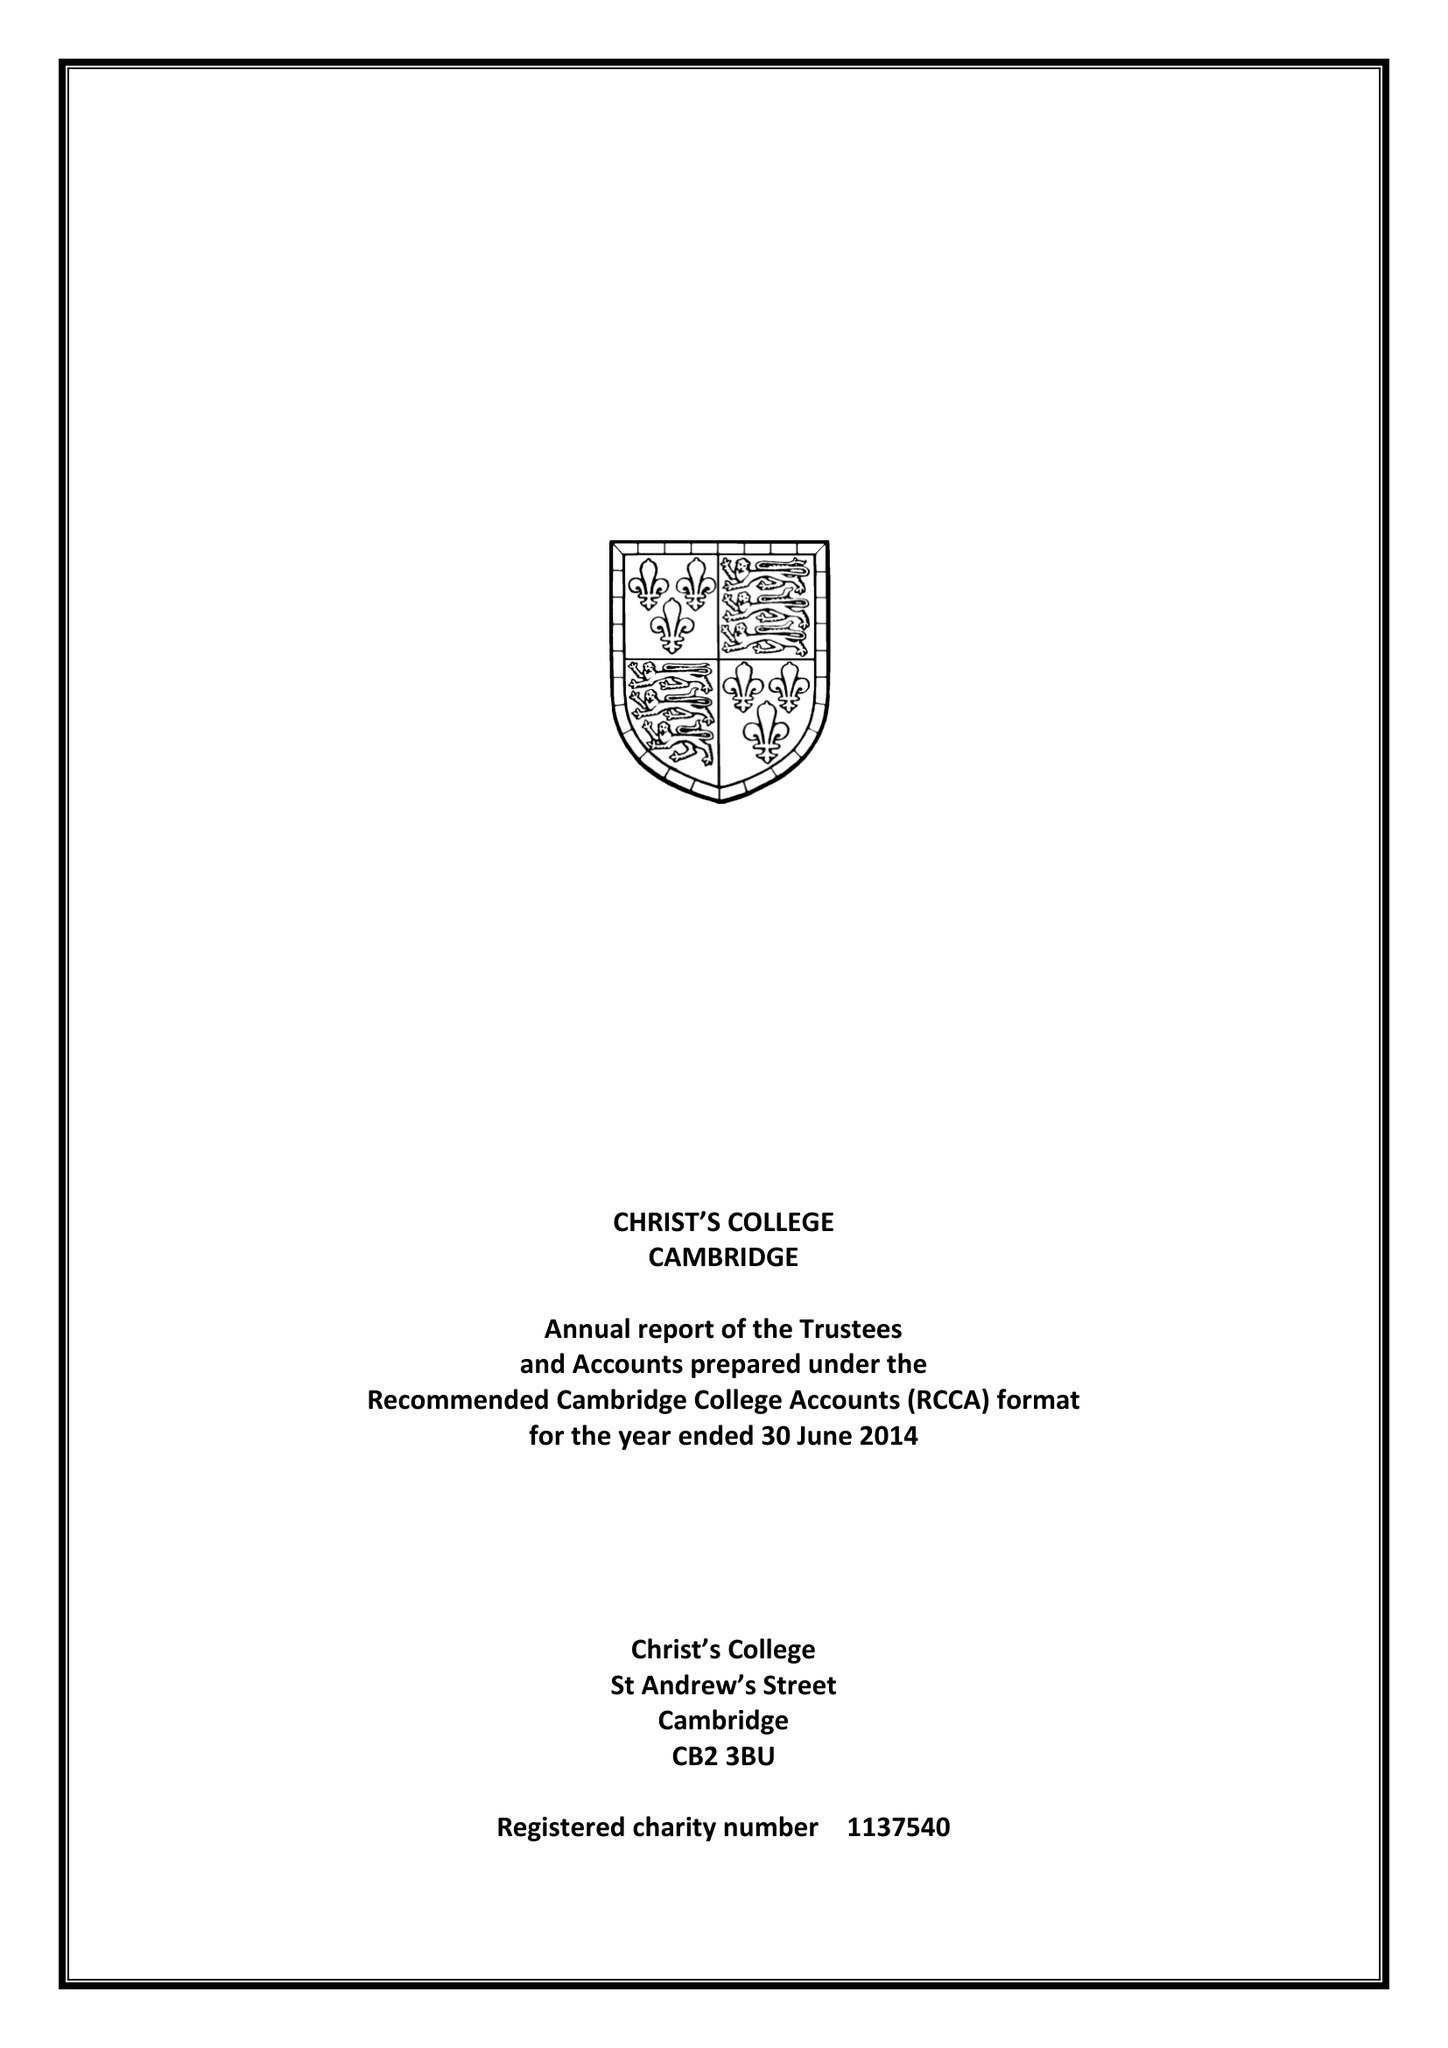What is the value for the charity_name?
Answer the question using a single word or phrase. Christ's College Cambridge In The University Of Cambridge First Founded By King Henry Vi Of England and After His Death 